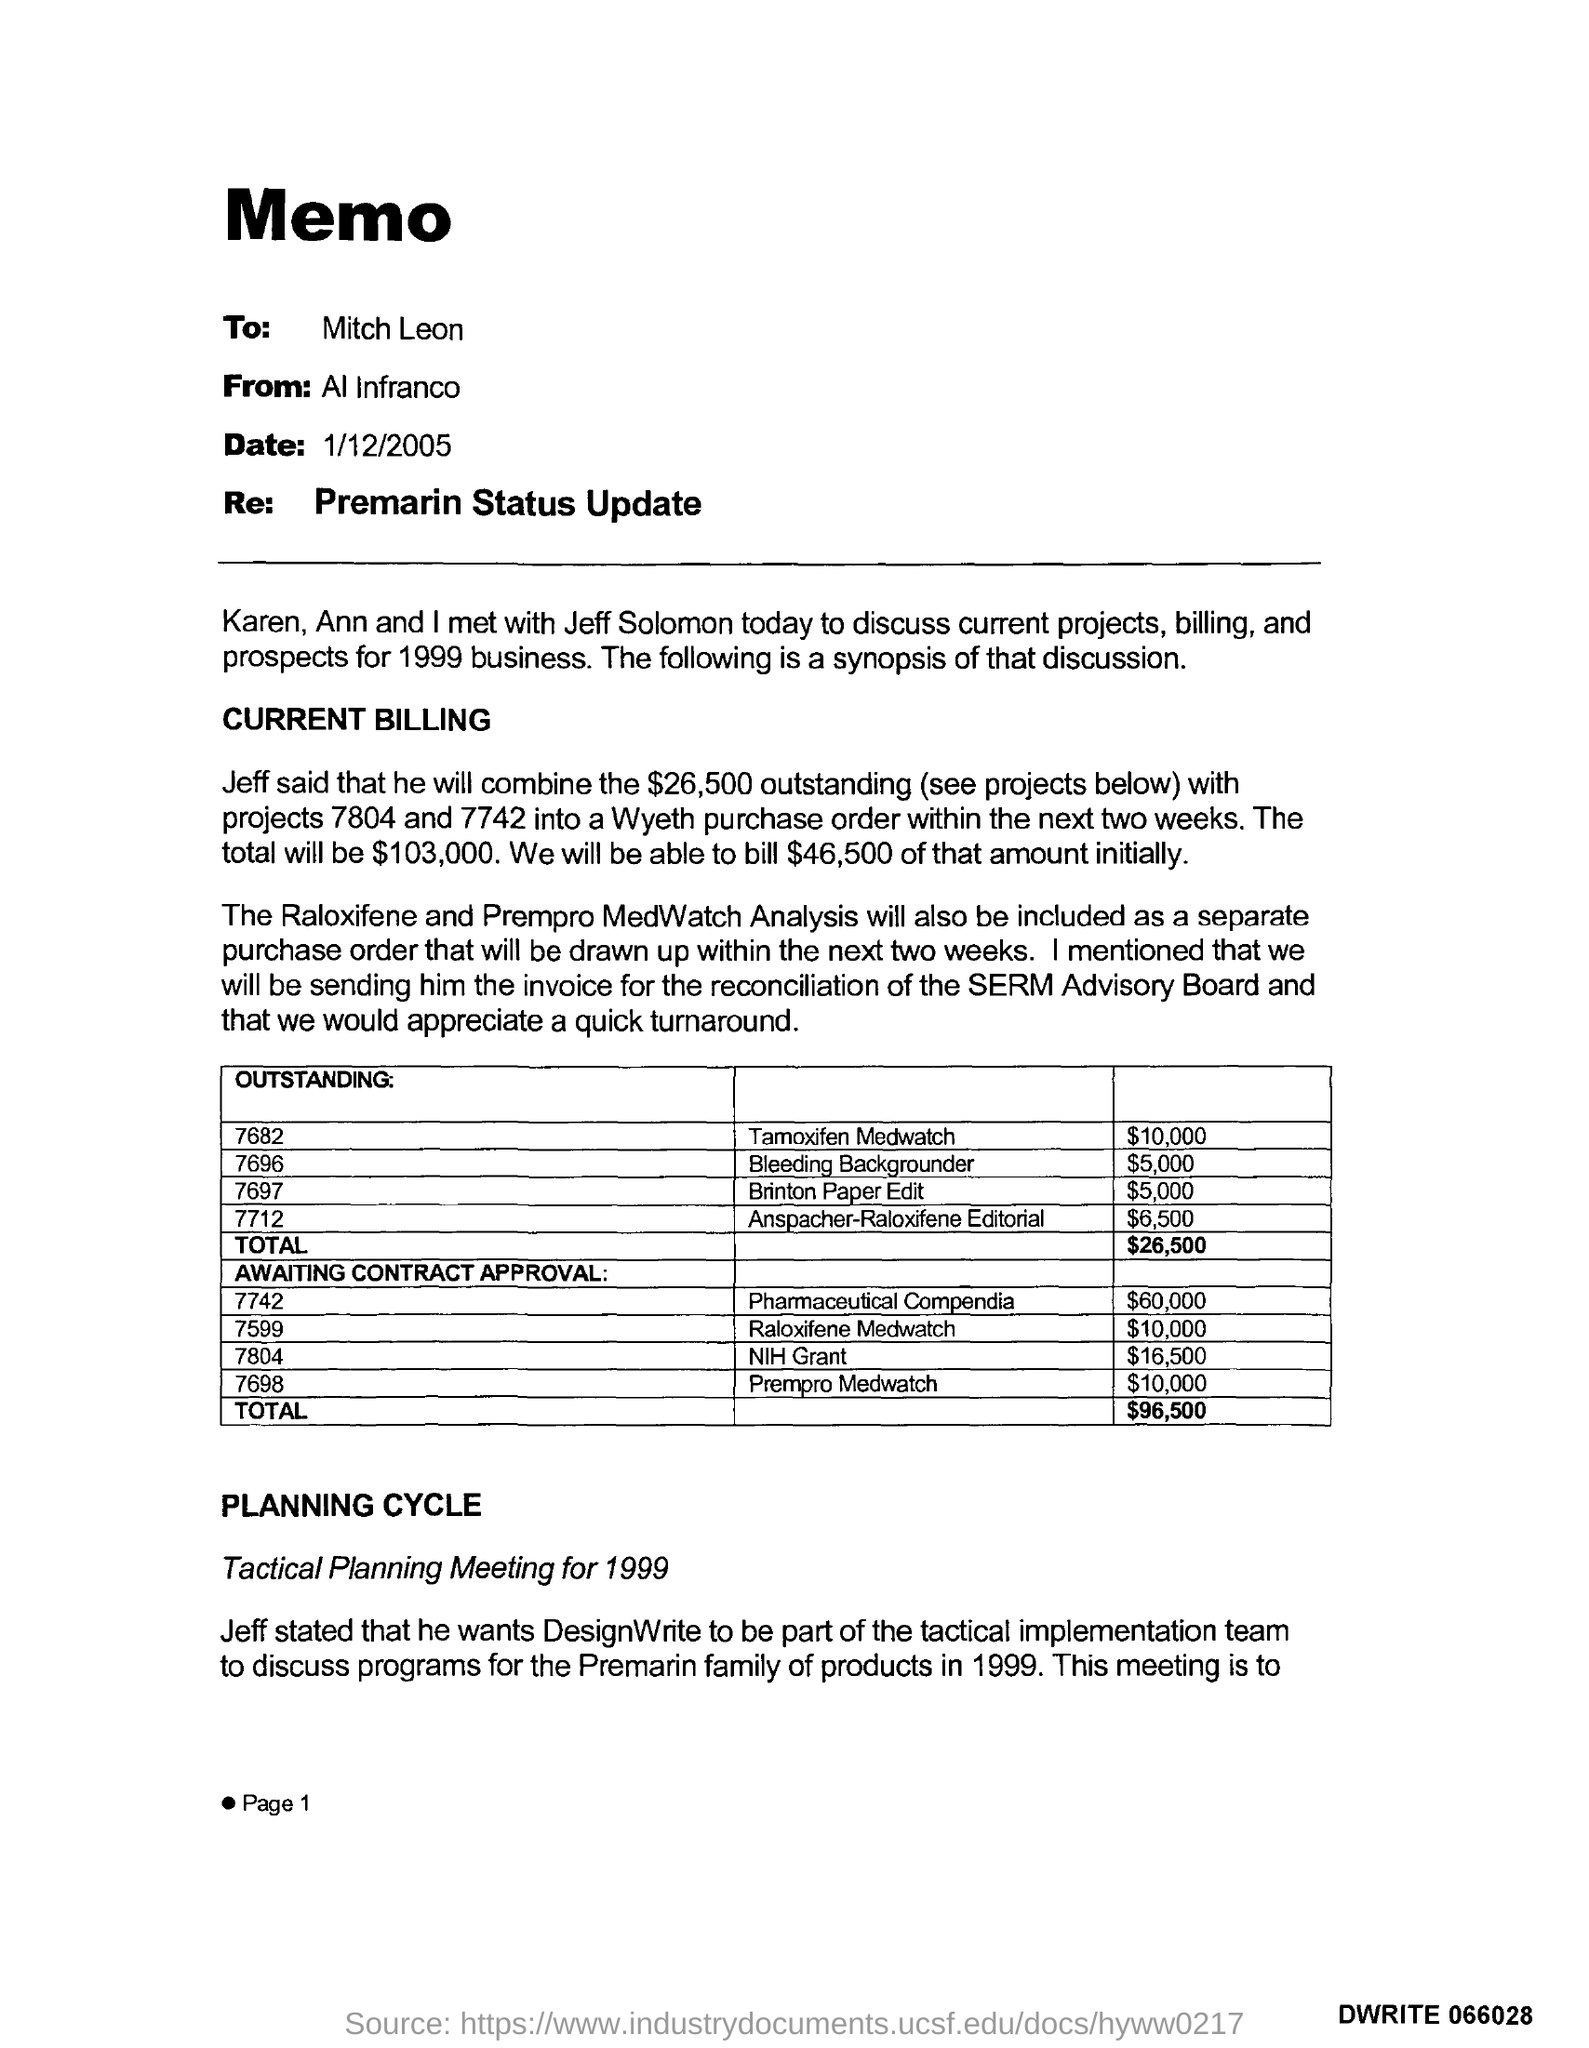Indicate a few pertinent items in this graphic. The date is January 12, 2005. The page number is 1.. 